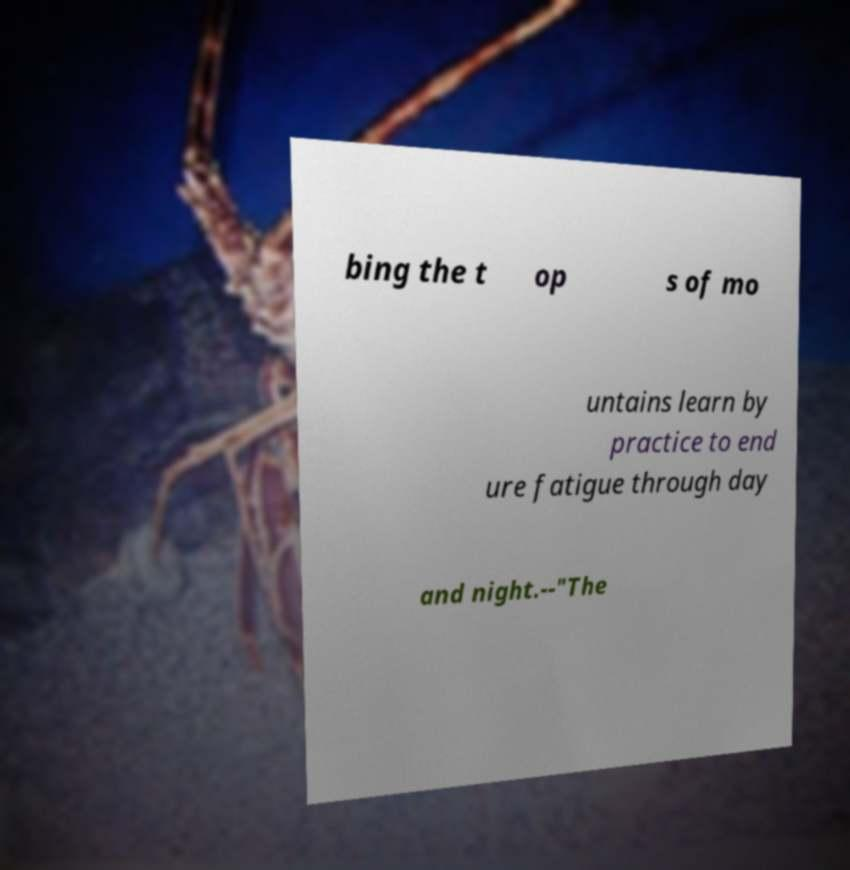Please identify and transcribe the text found in this image. bing the t op s of mo untains learn by practice to end ure fatigue through day and night.--"The 